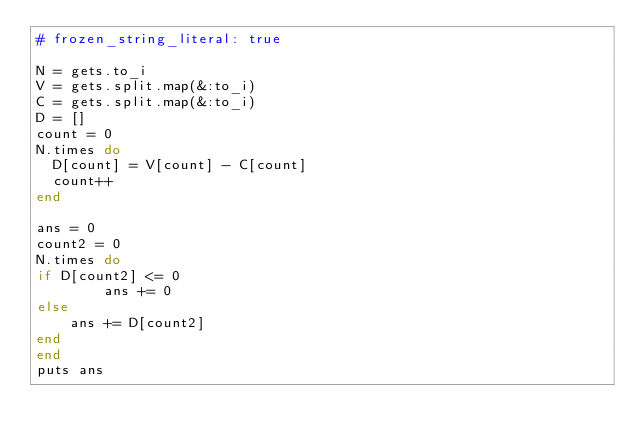Convert code to text. <code><loc_0><loc_0><loc_500><loc_500><_Ruby_># frozen_string_literal: true

N = gets.to_i
V = gets.split.map(&:to_i)
C = gets.split.map(&:to_i)
D = []
count = 0
N.times do
  D[count] = V[count] - C[count]
  count++
end

ans = 0
count2 = 0
N.times do
if D[count2] <= 0
        ans += 0
else
    ans += D[count2]
end
end
puts ans</code> 